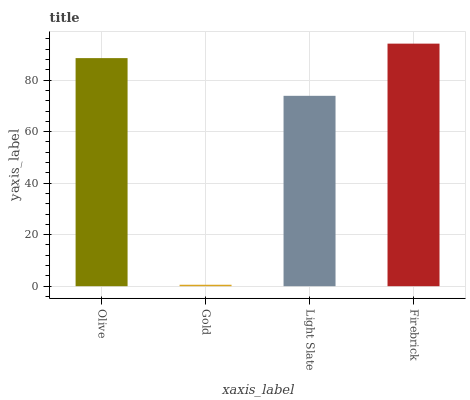Is Gold the minimum?
Answer yes or no. Yes. Is Firebrick the maximum?
Answer yes or no. Yes. Is Light Slate the minimum?
Answer yes or no. No. Is Light Slate the maximum?
Answer yes or no. No. Is Light Slate greater than Gold?
Answer yes or no. Yes. Is Gold less than Light Slate?
Answer yes or no. Yes. Is Gold greater than Light Slate?
Answer yes or no. No. Is Light Slate less than Gold?
Answer yes or no. No. Is Olive the high median?
Answer yes or no. Yes. Is Light Slate the low median?
Answer yes or no. Yes. Is Light Slate the high median?
Answer yes or no. No. Is Olive the low median?
Answer yes or no. No. 